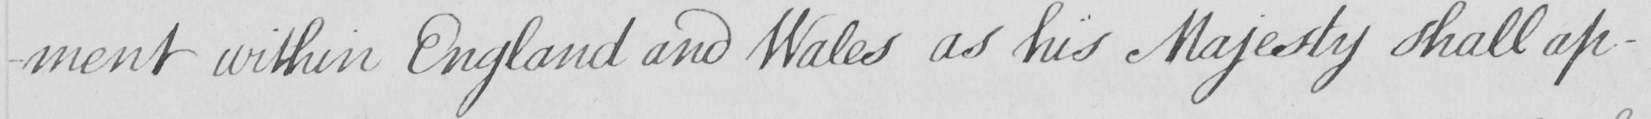What text is written in this handwritten line? -ment within England and Wales as his Majesty shall ap- 